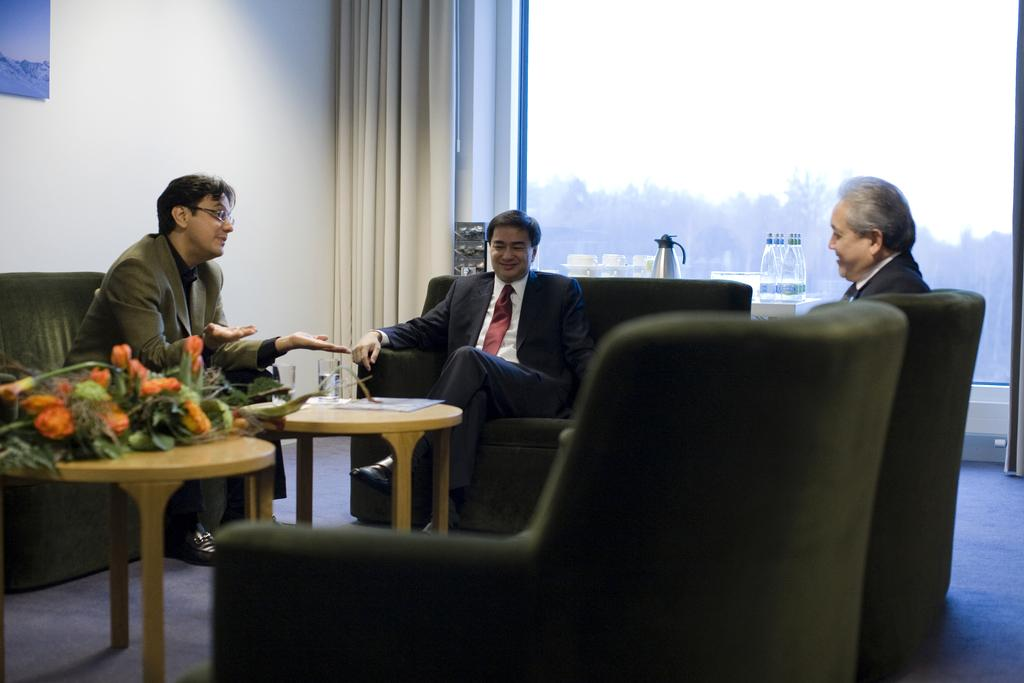What is the color of the wall in the image? The wall in the image is white. What is hanging near the window in the image? There is a curtain hanging near the window in the image. What is visible through the window in the image? There is a window in the image, but the view through it is not described in the facts. How many people are sitting on the sofa in the image? There are three people sitting on a sofa in the image. What is on the table in the image? There are flowers on the table in the image. What type of polish is being applied to the father's shoes in the image? There is no mention of a father or shoes in the image, so it is not possible to answer this question. 